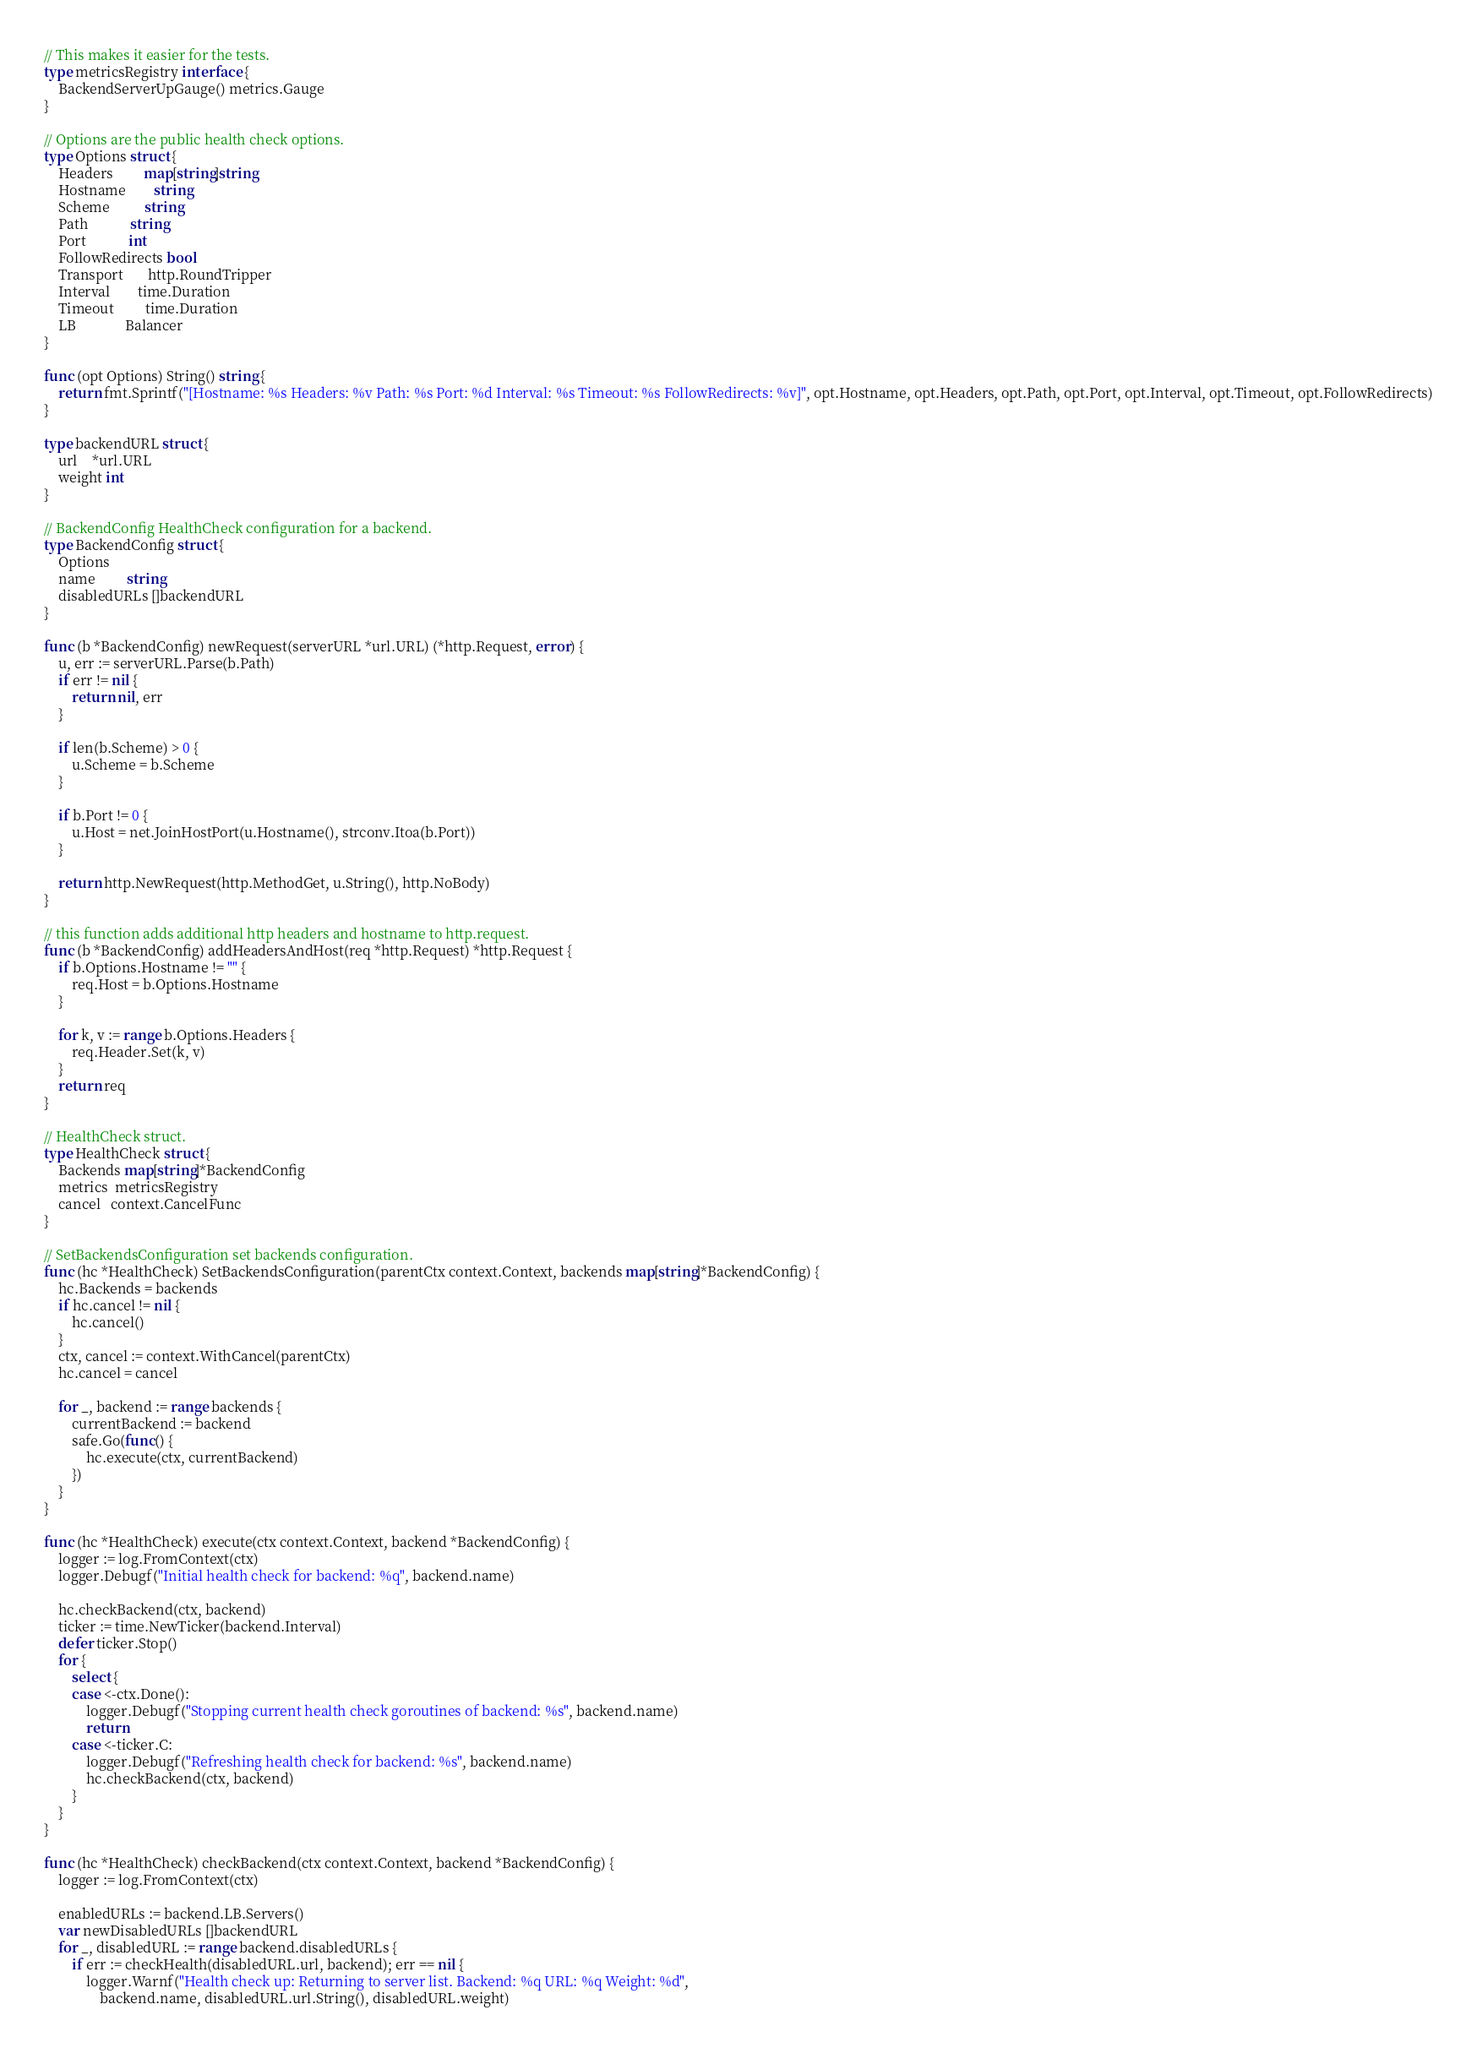<code> <loc_0><loc_0><loc_500><loc_500><_Go_>// This makes it easier for the tests.
type metricsRegistry interface {
	BackendServerUpGauge() metrics.Gauge
}

// Options are the public health check options.
type Options struct {
	Headers         map[string]string
	Hostname        string
	Scheme          string
	Path            string
	Port            int
	FollowRedirects bool
	Transport       http.RoundTripper
	Interval        time.Duration
	Timeout         time.Duration
	LB              Balancer
}

func (opt Options) String() string {
	return fmt.Sprintf("[Hostname: %s Headers: %v Path: %s Port: %d Interval: %s Timeout: %s FollowRedirects: %v]", opt.Hostname, opt.Headers, opt.Path, opt.Port, opt.Interval, opt.Timeout, opt.FollowRedirects)
}

type backendURL struct {
	url    *url.URL
	weight int
}

// BackendConfig HealthCheck configuration for a backend.
type BackendConfig struct {
	Options
	name         string
	disabledURLs []backendURL
}

func (b *BackendConfig) newRequest(serverURL *url.URL) (*http.Request, error) {
	u, err := serverURL.Parse(b.Path)
	if err != nil {
		return nil, err
	}

	if len(b.Scheme) > 0 {
		u.Scheme = b.Scheme
	}

	if b.Port != 0 {
		u.Host = net.JoinHostPort(u.Hostname(), strconv.Itoa(b.Port))
	}

	return http.NewRequest(http.MethodGet, u.String(), http.NoBody)
}

// this function adds additional http headers and hostname to http.request.
func (b *BackendConfig) addHeadersAndHost(req *http.Request) *http.Request {
	if b.Options.Hostname != "" {
		req.Host = b.Options.Hostname
	}

	for k, v := range b.Options.Headers {
		req.Header.Set(k, v)
	}
	return req
}

// HealthCheck struct.
type HealthCheck struct {
	Backends map[string]*BackendConfig
	metrics  metricsRegistry
	cancel   context.CancelFunc
}

// SetBackendsConfiguration set backends configuration.
func (hc *HealthCheck) SetBackendsConfiguration(parentCtx context.Context, backends map[string]*BackendConfig) {
	hc.Backends = backends
	if hc.cancel != nil {
		hc.cancel()
	}
	ctx, cancel := context.WithCancel(parentCtx)
	hc.cancel = cancel

	for _, backend := range backends {
		currentBackend := backend
		safe.Go(func() {
			hc.execute(ctx, currentBackend)
		})
	}
}

func (hc *HealthCheck) execute(ctx context.Context, backend *BackendConfig) {
	logger := log.FromContext(ctx)
	logger.Debugf("Initial health check for backend: %q", backend.name)

	hc.checkBackend(ctx, backend)
	ticker := time.NewTicker(backend.Interval)
	defer ticker.Stop()
	for {
		select {
		case <-ctx.Done():
			logger.Debugf("Stopping current health check goroutines of backend: %s", backend.name)
			return
		case <-ticker.C:
			logger.Debugf("Refreshing health check for backend: %s", backend.name)
			hc.checkBackend(ctx, backend)
		}
	}
}

func (hc *HealthCheck) checkBackend(ctx context.Context, backend *BackendConfig) {
	logger := log.FromContext(ctx)

	enabledURLs := backend.LB.Servers()
	var newDisabledURLs []backendURL
	for _, disabledURL := range backend.disabledURLs {
		if err := checkHealth(disabledURL.url, backend); err == nil {
			logger.Warnf("Health check up: Returning to server list. Backend: %q URL: %q Weight: %d",
				backend.name, disabledURL.url.String(), disabledURL.weight)</code> 